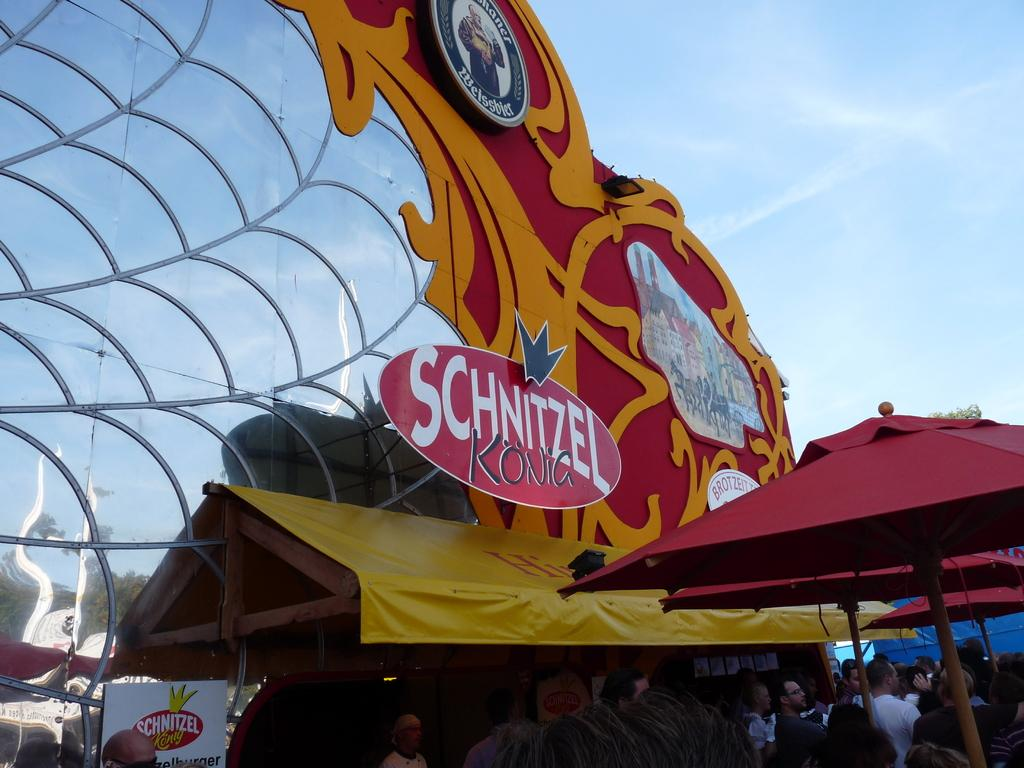<image>
Create a compact narrative representing the image presented. A vendor at a public event with a sign that says Schnitzel Kong. 